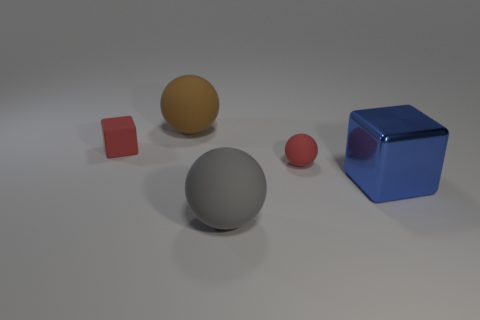Add 3 tiny purple rubber balls. How many objects exist? 8 Subtract all blocks. How many objects are left? 3 Add 4 brown rubber balls. How many brown rubber balls exist? 5 Subtract 0 cyan cylinders. How many objects are left? 5 Subtract all red matte blocks. Subtract all small gray cylinders. How many objects are left? 4 Add 3 red things. How many red things are left? 5 